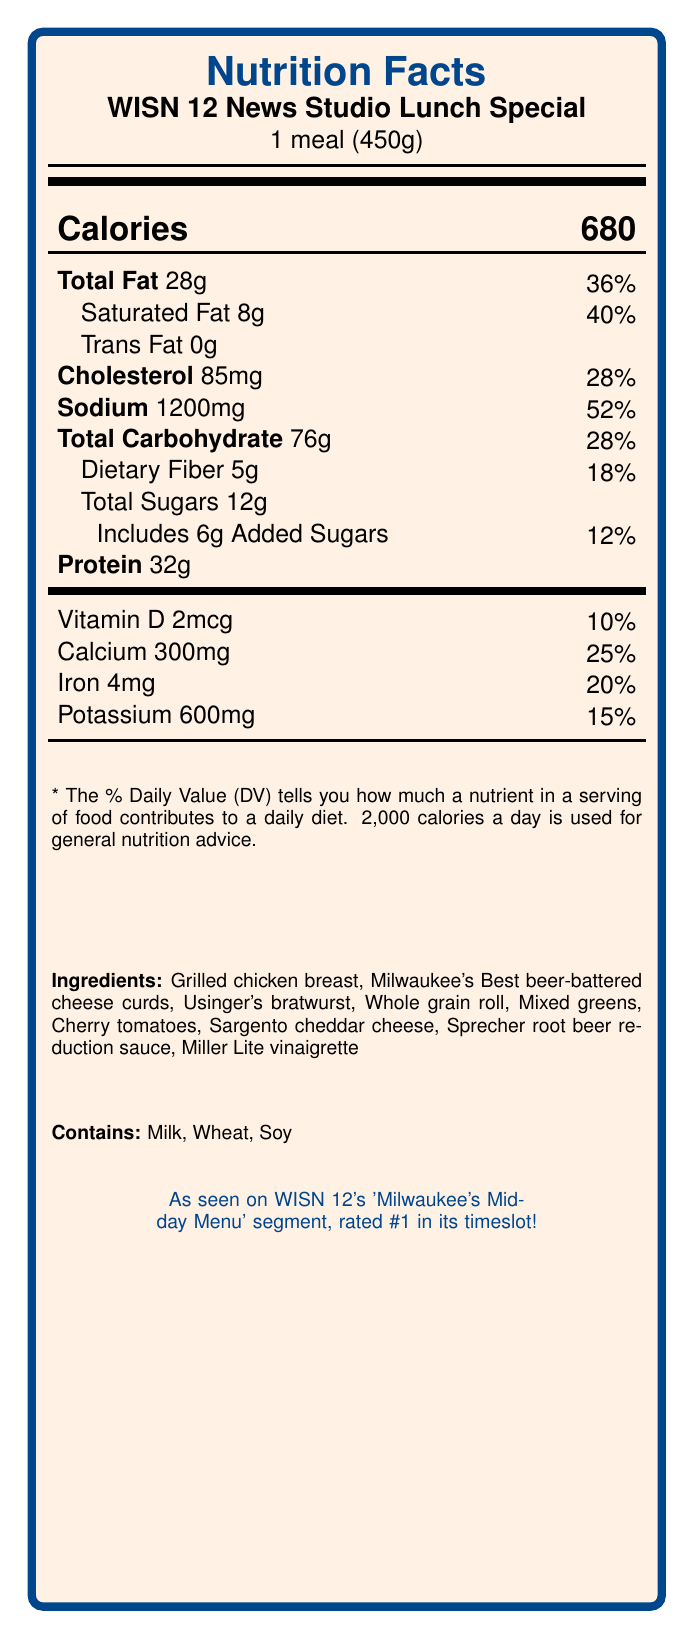what is the serving size of the WISN 12 News Studio Lunch Special? The document specifies the serving size as "1 meal (450g)."
Answer: 1 meal (450g) what are the main ingredients in the WISN 12 News Studio Lunch Special? The ingredients list in the document includes all these items.
Answer: Grilled chicken breast, Milwaukee's Best beer-battered cheese curds, Usinger's bratwurst, Whole grain roll, Mixed greens, Cherry tomatoes, Sargento cheddar cheese, Sprecher root beer reduction sauce, Miller Lite vinaigrette how much protein does one serving of the WISN 12 News Studio Lunch Special contain? The document states that one serving contains 32g of protein.
Answer: 32g what is the percentage daily value of sodium in the meal? The document shows that sodium contributes to 52% of the daily value.
Answer: 52% what allergens are present in the meal? The document clearly lists the allergens as "Milk, Wheat, Soy."
Answer: Milk, Wheat, Soy how many calories are in one serving of the WISN 12 News Studio Lunch Special? The document specifies that the meal contains 680 calories.
Answer: 680 calories what is the total amount of carbohydrates in the meal? The document mentions that the total carbohydrate content is 76g.
Answer: 76g Which of the following foods is NOT an ingredient in the WISN 12 News Studio Lunch Special? A. Cherry tomatoes B. Whole grain roll C. Avocado D. Grilled chicken breast The document does not list avocado as one of the ingredients.
Answer: C. Avocado What is the percentage daily value of saturated fat? A. 25% B. 30% C. 35% D. 40% According to the document, the saturated fat contributes to 40% of the daily value.
Answer: D. 40% Is there any trans fat in the meal? The document states that the trans fat amount is 0g.
Answer: No Describe the main idea of the document. The document provides detailed nutritional information and ingredient details of the studio lunch special featured on WISN 12's 'Milwaukee's Midday Menu' segment.
Answer: The document presents the nutrition facts for the WISN 12 News Studio Lunch Special, including the serving size, calorie count, fat content, cholesterol, sodium, carbohydrates, protein, and vitamins. It also lists the ingredients and allergens. What is the exact percentage daily value of Vitamin D in the meal? The document provides the amount of Vitamin D as 2mcg and a daily value percentage of 10%, but it doesn't give the exact daily value percentage without this context.
Answer: Not enough information 